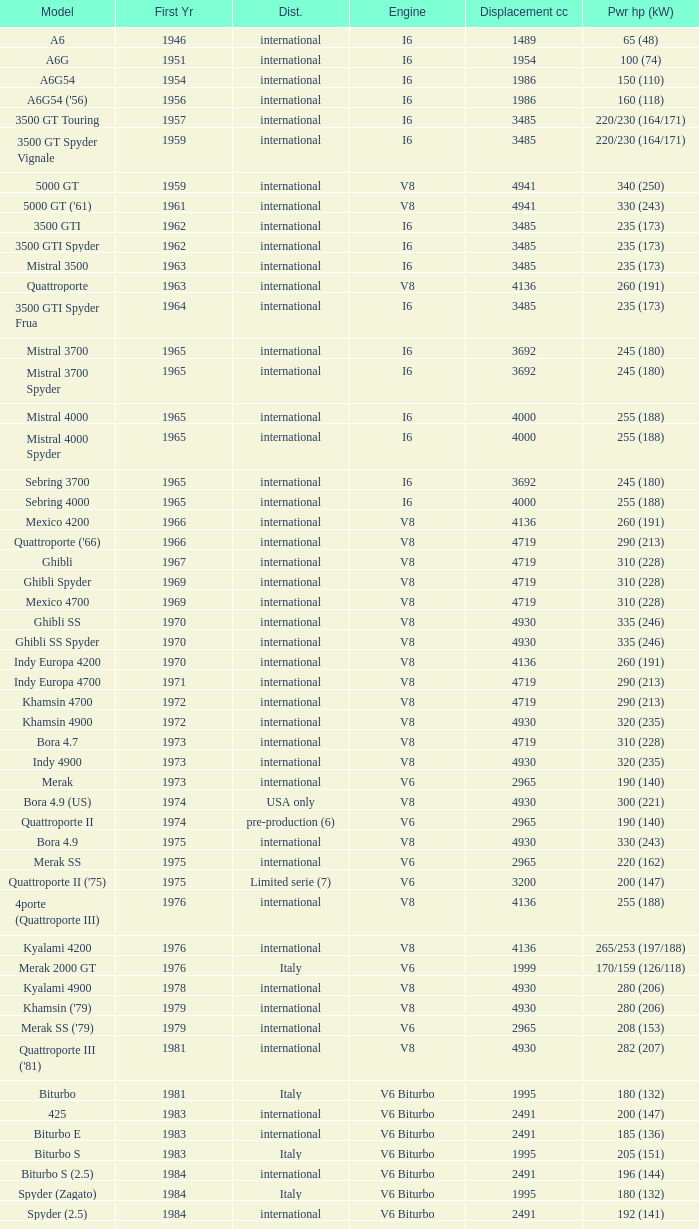What is Power HP (kW), when First Year is greater than 1965, when Distribution is "International", when Engine is V6 Biturbo, and when Model is "425"? 200 (147). 